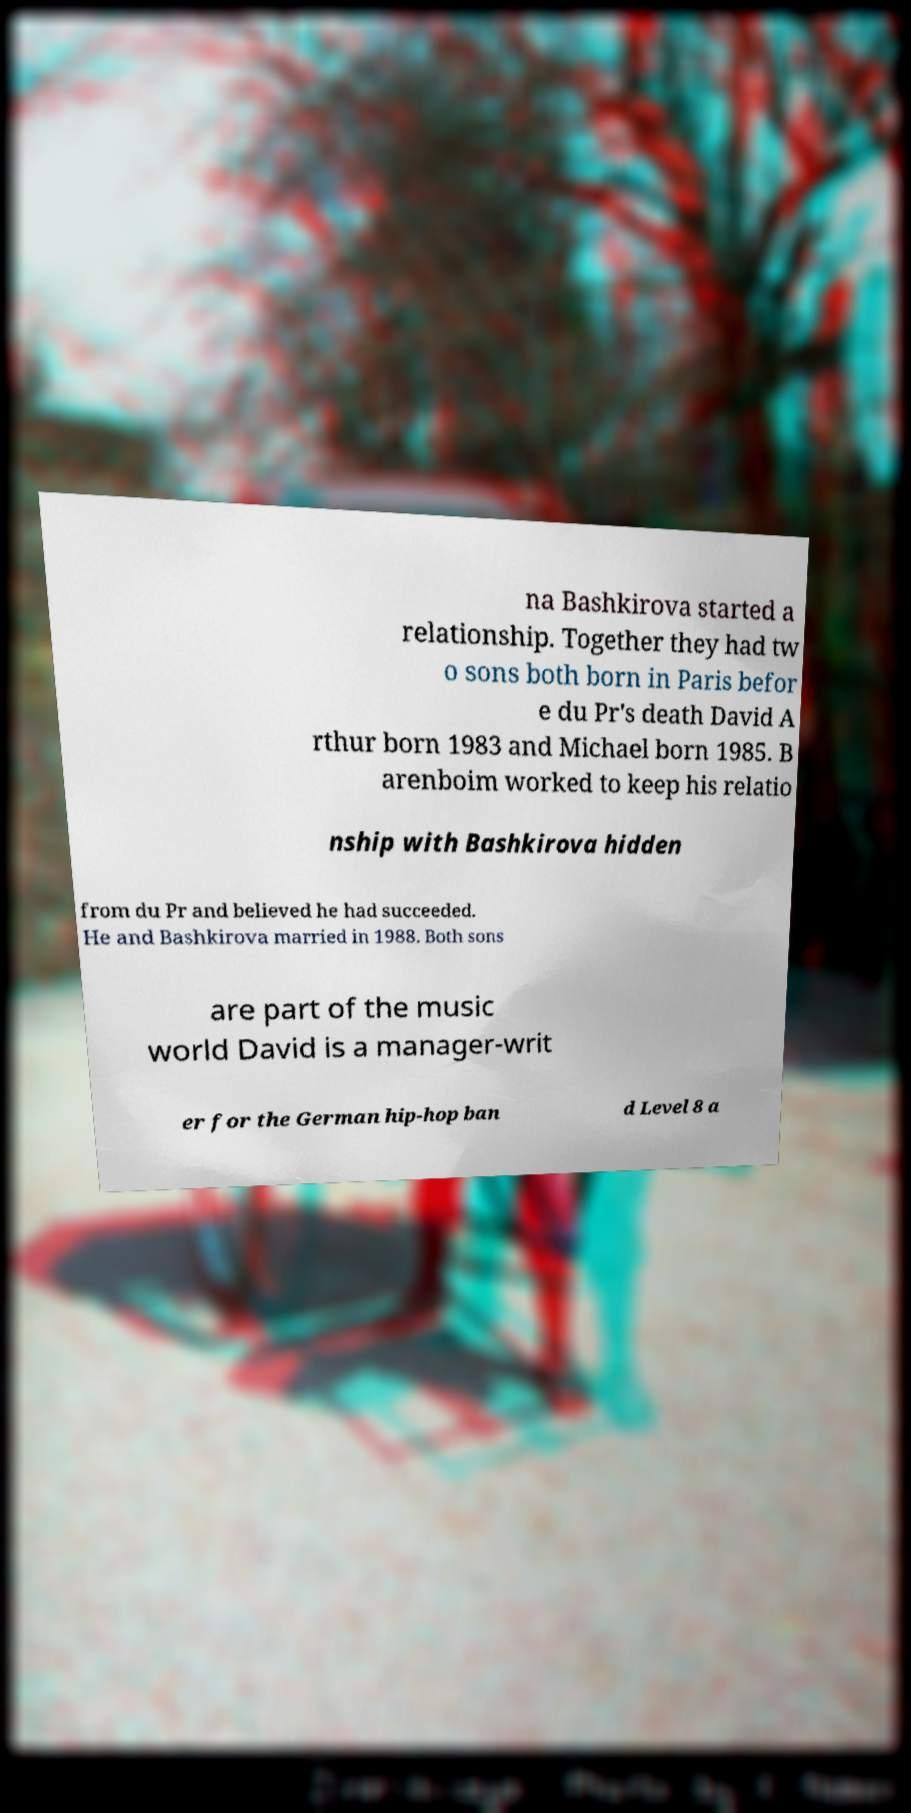Please read and relay the text visible in this image. What does it say? na Bashkirova started a relationship. Together they had tw o sons both born in Paris befor e du Pr's death David A rthur born 1983 and Michael born 1985. B arenboim worked to keep his relatio nship with Bashkirova hidden from du Pr and believed he had succeeded. He and Bashkirova married in 1988. Both sons are part of the music world David is a manager-writ er for the German hip-hop ban d Level 8 a 